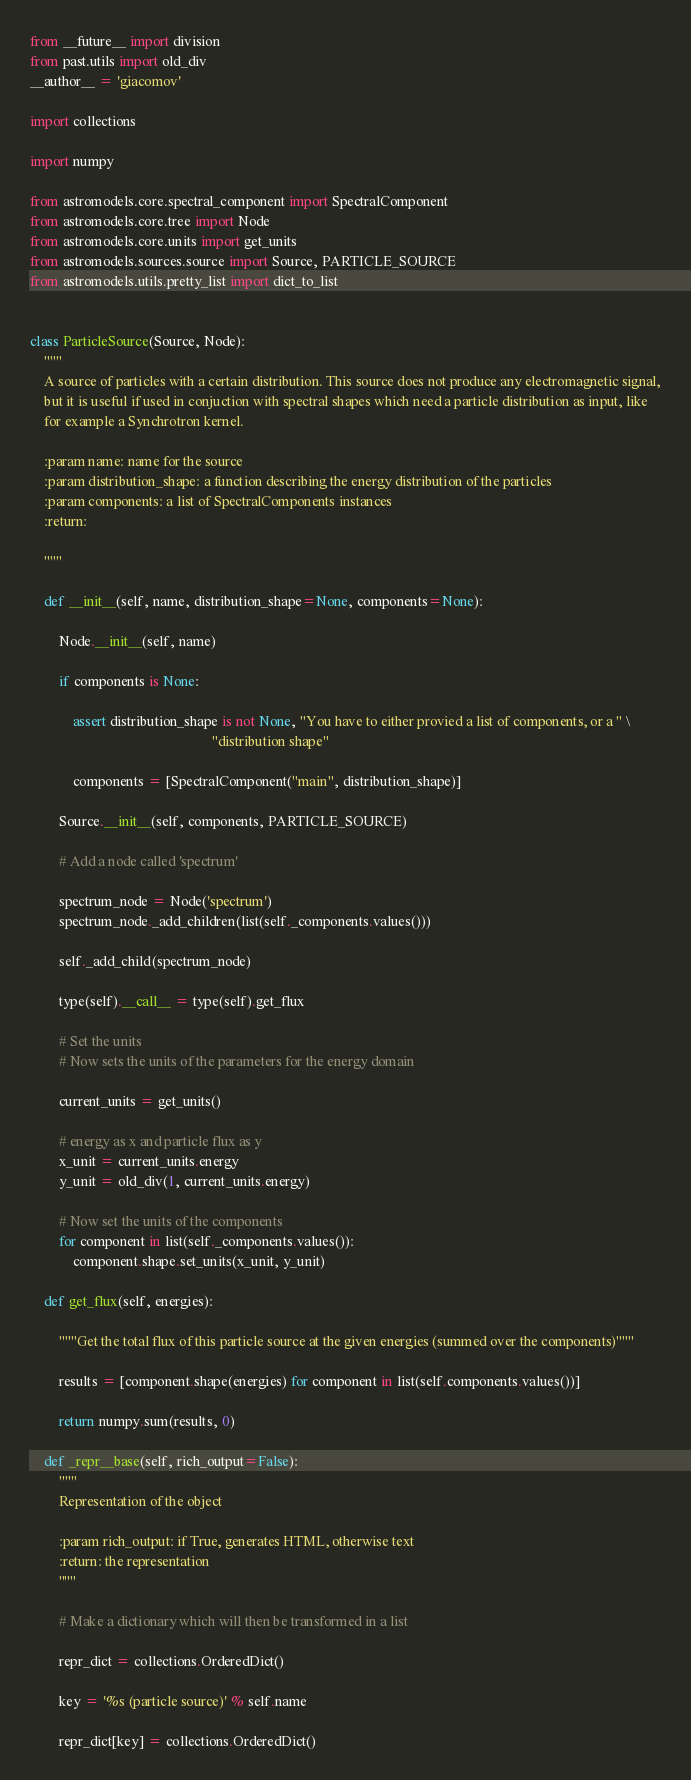<code> <loc_0><loc_0><loc_500><loc_500><_Python_>from __future__ import division
from past.utils import old_div
__author__ = 'giacomov'

import collections

import numpy

from astromodels.core.spectral_component import SpectralComponent
from astromodels.core.tree import Node
from astromodels.core.units import get_units
from astromodels.sources.source import Source, PARTICLE_SOURCE
from astromodels.utils.pretty_list import dict_to_list


class ParticleSource(Source, Node):
    """
    A source of particles with a certain distribution. This source does not produce any electromagnetic signal,
    but it is useful if used in conjuction with spectral shapes which need a particle distribution as input, like
    for example a Synchrotron kernel.

    :param name: name for the source
    :param distribution_shape: a function describing the energy distribution of the particles
    :param components: a list of SpectralComponents instances
    :return:

    """

    def __init__(self, name, distribution_shape=None, components=None):

        Node.__init__(self, name)

        if components is None:

            assert distribution_shape is not None, "You have to either provied a list of components, or a " \
                                                   "distribution shape"

            components = [SpectralComponent("main", distribution_shape)]

        Source.__init__(self, components, PARTICLE_SOURCE)

        # Add a node called 'spectrum'

        spectrum_node = Node('spectrum')
        spectrum_node._add_children(list(self._components.values()))

        self._add_child(spectrum_node)

        type(self).__call__ = type(self).get_flux

        # Set the units
        # Now sets the units of the parameters for the energy domain

        current_units = get_units()

        # energy as x and particle flux as y
        x_unit = current_units.energy
        y_unit = old_div(1, current_units.energy)

        # Now set the units of the components
        for component in list(self._components.values()):
            component.shape.set_units(x_unit, y_unit)

    def get_flux(self, energies):

        """Get the total flux of this particle source at the given energies (summed over the components)"""

        results = [component.shape(energies) for component in list(self.components.values())]

        return numpy.sum(results, 0)

    def _repr__base(self, rich_output=False):
        """
        Representation of the object

        :param rich_output: if True, generates HTML, otherwise text
        :return: the representation
        """

        # Make a dictionary which will then be transformed in a list

        repr_dict = collections.OrderedDict()

        key = '%s (particle source)' % self.name

        repr_dict[key] = collections.OrderedDict()</code> 